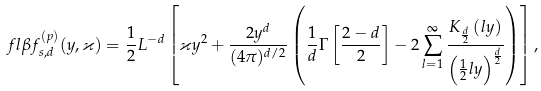<formula> <loc_0><loc_0><loc_500><loc_500>\ f l \beta f _ { s , d } ^ { ( p ) } ( y , \varkappa ) = \frac { 1 } { 2 } L ^ { - d } \left [ \varkappa y ^ { 2 } + \frac { 2 y ^ { d } } { ( 4 \pi ) ^ { d / 2 } } \left ( \frac { 1 } { d } \Gamma \left [ \frac { 2 - d } 2 \right ] - 2 \sum _ { l = 1 } ^ { \infty } \frac { K _ { \frac { d } { 2 } } \left ( l y \right ) } { \left ( \frac { 1 } { 2 } l y \right ) ^ { \frac { d } { 2 } } } \right ) \right ] ,</formula> 